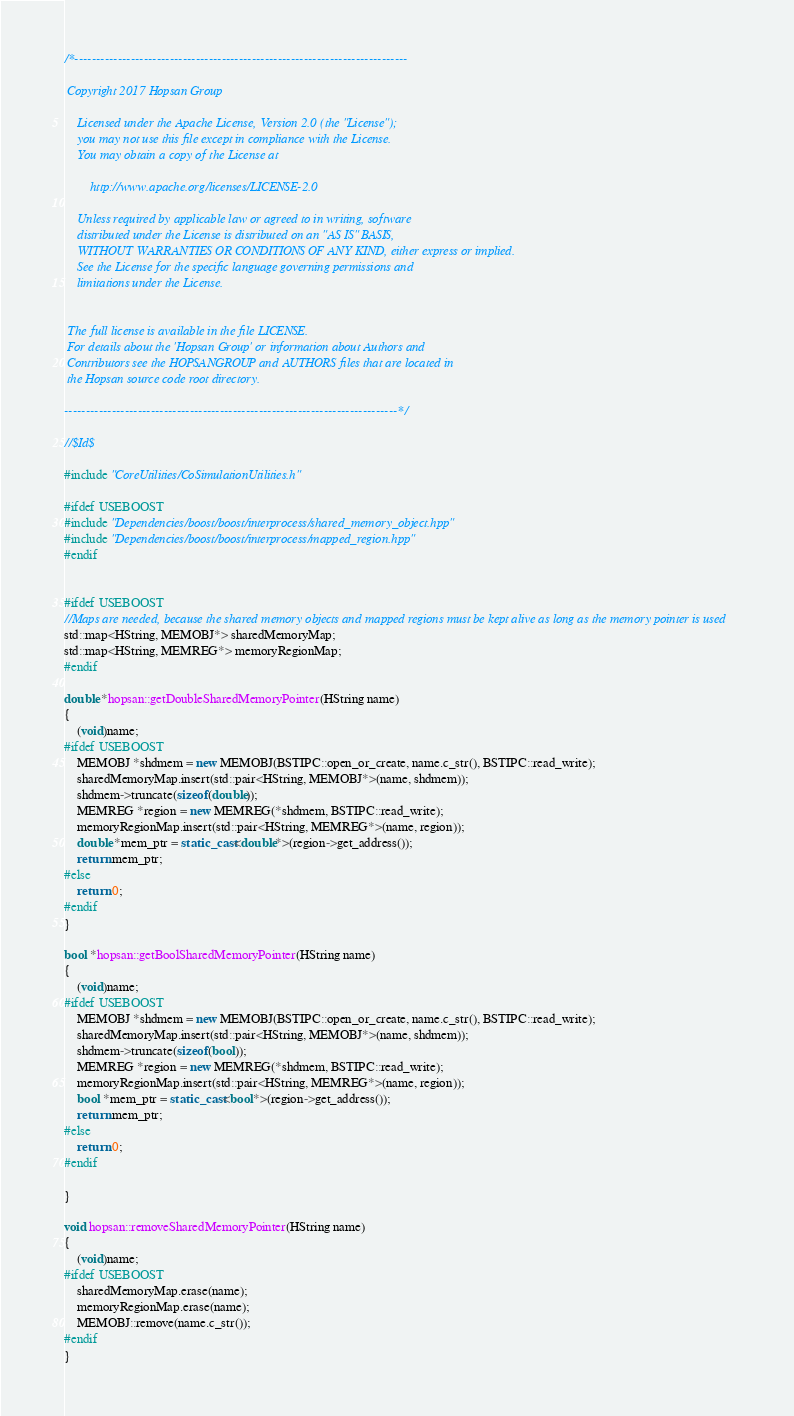Convert code to text. <code><loc_0><loc_0><loc_500><loc_500><_C++_>/*-----------------------------------------------------------------------------

 Copyright 2017 Hopsan Group

    Licensed under the Apache License, Version 2.0 (the "License");
    you may not use this file except in compliance with the License.
    You may obtain a copy of the License at

        http://www.apache.org/licenses/LICENSE-2.0

    Unless required by applicable law or agreed to in writing, software
    distributed under the License is distributed on an "AS IS" BASIS,
    WITHOUT WARRANTIES OR CONDITIONS OF ANY KIND, either express or implied.
    See the License for the specific language governing permissions and
    limitations under the License.


 The full license is available in the file LICENSE.
 For details about the 'Hopsan Group' or information about Authors and
 Contributors see the HOPSANGROUP and AUTHORS files that are located in
 the Hopsan source code root directory.

-----------------------------------------------------------------------------*/

//$Id$

#include "CoreUtilities/CoSimulationUtilities.h"

#ifdef USEBOOST
#include "Dependencies/boost/boost/interprocess/shared_memory_object.hpp"
#include "Dependencies/boost/boost/interprocess/mapped_region.hpp"
#endif


#ifdef USEBOOST
//Maps are needed, because the shared memory objects and mapped regions must be kept alive as long as the memory pointer is used
std::map<HString, MEMOBJ*> sharedMemoryMap;
std::map<HString, MEMREG*> memoryRegionMap;
#endif

double *hopsan::getDoubleSharedMemoryPointer(HString name)
{
    (void)name;
#ifdef USEBOOST
    MEMOBJ *shdmem = new MEMOBJ(BSTIPC::open_or_create, name.c_str(), BSTIPC::read_write);
    sharedMemoryMap.insert(std::pair<HString, MEMOBJ*>(name, shdmem));
    shdmem->truncate(sizeof(double));
    MEMREG *region = new MEMREG(*shdmem, BSTIPC::read_write);
    memoryRegionMap.insert(std::pair<HString, MEMREG*>(name, region));
    double *mem_ptr = static_cast<double*>(region->get_address());
    return mem_ptr;
#else
    return 0;
#endif
}

bool *hopsan::getBoolSharedMemoryPointer(HString name)
{
    (void)name;
#ifdef USEBOOST
    MEMOBJ *shdmem = new MEMOBJ(BSTIPC::open_or_create, name.c_str(), BSTIPC::read_write);
    sharedMemoryMap.insert(std::pair<HString, MEMOBJ*>(name, shdmem));
    shdmem->truncate(sizeof(bool));
    MEMREG *region = new MEMREG(*shdmem, BSTIPC::read_write);
    memoryRegionMap.insert(std::pair<HString, MEMREG*>(name, region));
    bool *mem_ptr = static_cast<bool*>(region->get_address());
    return mem_ptr;
#else
    return 0;
#endif

}

void hopsan::removeSharedMemoryPointer(HString name)
{
    (void)name;
#ifdef USEBOOST
    sharedMemoryMap.erase(name);
    memoryRegionMap.erase(name);
    MEMOBJ::remove(name.c_str());
#endif
}

</code> 